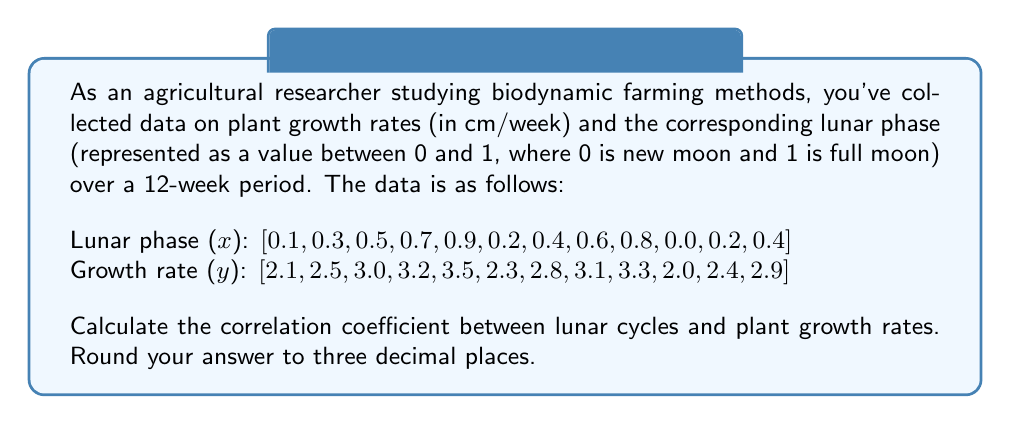Can you solve this math problem? To calculate the correlation coefficient, we'll use the formula:

$$ r = \frac{\sum_{i=1}^{n} (x_i - \bar{x})(y_i - \bar{y})}{\sqrt{\sum_{i=1}^{n} (x_i - \bar{x})^2 \sum_{i=1}^{n} (y_i - \bar{y})^2}} $$

Step 1: Calculate the means $\bar{x}$ and $\bar{y}$
$\bar{x} = \frac{1}{12} \sum x_i = 0.425$
$\bar{y} = \frac{1}{12} \sum y_i = 2.758$

Step 2: Calculate $(x_i - \bar{x})$, $(y_i - \bar{y})$, $(x_i - \bar{x})^2$, $(y_i - \bar{y})^2$, and $(x_i - \bar{x})(y_i - \bar{y})$ for each pair

Step 3: Sum up the calculated values
$\sum (x_i - \bar{x})(y_i - \bar{y}) = 0.4605$
$\sum (x_i - \bar{x})^2 = 0.8075$
$\sum (y_i - \bar{y})^2 = 2.8634$

Step 4: Apply the correlation coefficient formula
$$ r = \frac{0.4605}{\sqrt{0.8075 \times 2.8634}} = 0.9564 $$

Step 5: Round to three decimal places
$r \approx 0.956$
Answer: 0.956 